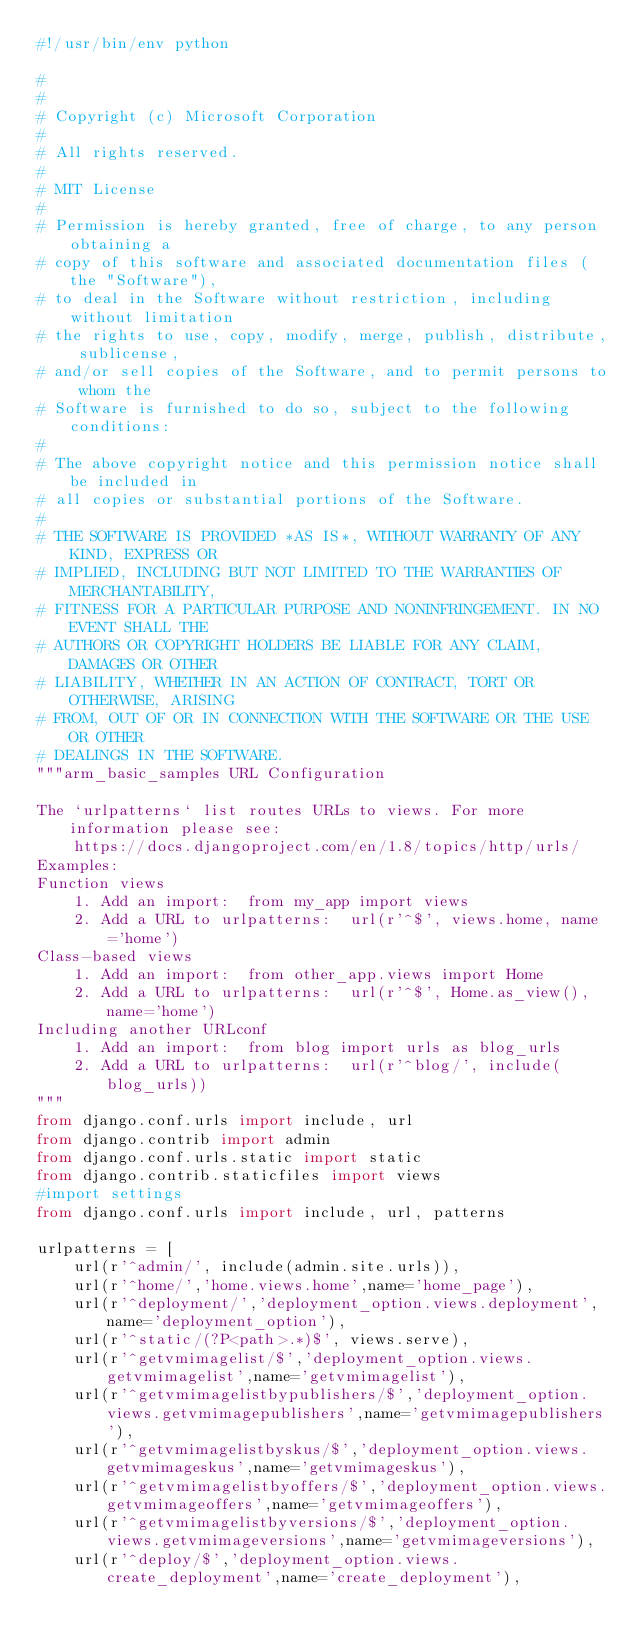<code> <loc_0><loc_0><loc_500><loc_500><_Python_>#!/usr/bin/env python

#
#
# Copyright (c) Microsoft Corporation
#
# All rights reserved.
#
# MIT License
#
# Permission is hereby granted, free of charge, to any person obtaining a
# copy of this software and associated documentation files (the "Software"),
# to deal in the Software without restriction, including without limitation
# the rights to use, copy, modify, merge, publish, distribute, sublicense,
# and/or sell copies of the Software, and to permit persons to whom the
# Software is furnished to do so, subject to the following conditions:
#
# The above copyright notice and this permission notice shall be included in
# all copies or substantial portions of the Software.
#
# THE SOFTWARE IS PROVIDED *AS IS*, WITHOUT WARRANTY OF ANY KIND, EXPRESS OR
# IMPLIED, INCLUDING BUT NOT LIMITED TO THE WARRANTIES OF MERCHANTABILITY,
# FITNESS FOR A PARTICULAR PURPOSE AND NONINFRINGEMENT. IN NO EVENT SHALL THE
# AUTHORS OR COPYRIGHT HOLDERS BE LIABLE FOR ANY CLAIM, DAMAGES OR OTHER
# LIABILITY, WHETHER IN AN ACTION OF CONTRACT, TORT OR OTHERWISE, ARISING
# FROM, OUT OF OR IN CONNECTION WITH THE SOFTWARE OR THE USE OR OTHER
# DEALINGS IN THE SOFTWARE.
"""arm_basic_samples URL Configuration

The `urlpatterns` list routes URLs to views. For more information please see:
    https://docs.djangoproject.com/en/1.8/topics/http/urls/
Examples:
Function views
    1. Add an import:  from my_app import views
    2. Add a URL to urlpatterns:  url(r'^$', views.home, name='home')
Class-based views
    1. Add an import:  from other_app.views import Home
    2. Add a URL to urlpatterns:  url(r'^$', Home.as_view(), name='home')
Including another URLconf
    1. Add an import:  from blog import urls as blog_urls
    2. Add a URL to urlpatterns:  url(r'^blog/', include(blog_urls))
"""
from django.conf.urls import include, url
from django.contrib import admin
from django.conf.urls.static import static
from django.contrib.staticfiles import views
#import settings
from django.conf.urls import include, url, patterns

urlpatterns = [
    url(r'^admin/', include(admin.site.urls)),
    url(r'^home/','home.views.home',name='home_page'),
    url(r'^deployment/','deployment_option.views.deployment',name='deployment_option'),
    url(r'^static/(?P<path>.*)$', views.serve),
    url(r'^getvmimagelist/$','deployment_option.views.getvmimagelist',name='getvmimagelist'),    
    url(r'^getvmimagelistbypublishers/$','deployment_option.views.getvmimagepublishers',name='getvmimagepublishers'),
    url(r'^getvmimagelistbyskus/$','deployment_option.views.getvmimageskus',name='getvmimageskus'),
    url(r'^getvmimagelistbyoffers/$','deployment_option.views.getvmimageoffers',name='getvmimageoffers'),
    url(r'^getvmimagelistbyversions/$','deployment_option.views.getvmimageversions',name='getvmimageversions'),    
    url(r'^deploy/$','deployment_option.views.create_deployment',name='create_deployment'),</code> 